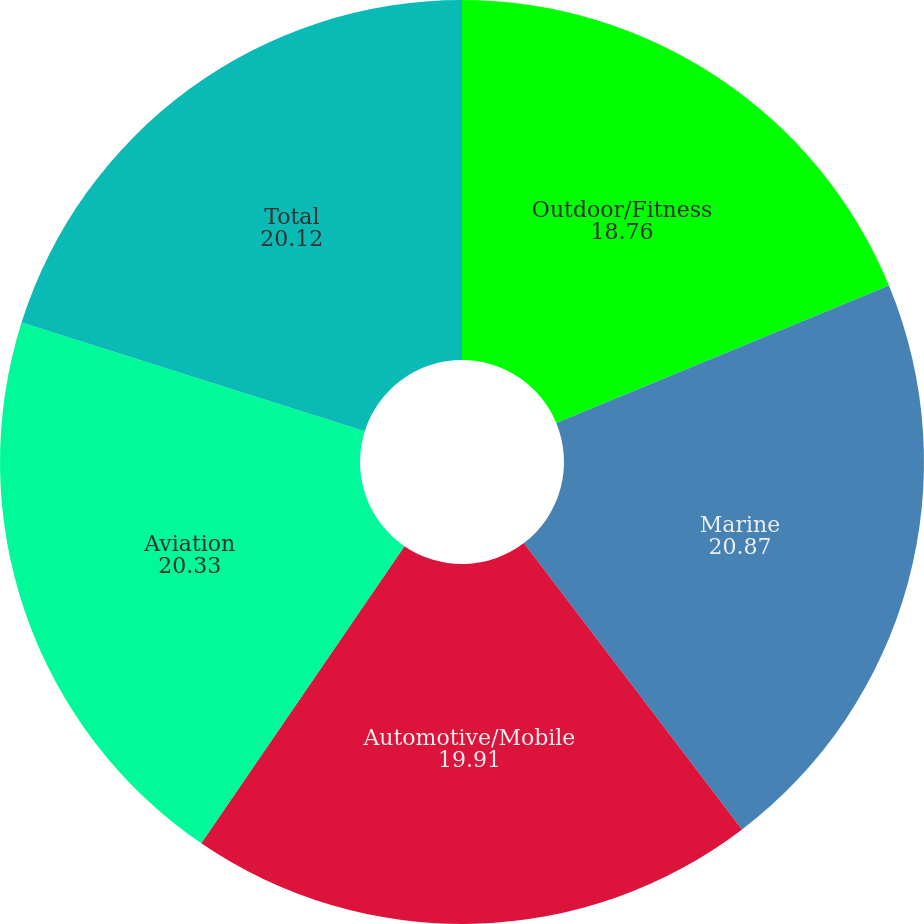Convert chart to OTSL. <chart><loc_0><loc_0><loc_500><loc_500><pie_chart><fcel>Outdoor/Fitness<fcel>Marine<fcel>Automotive/Mobile<fcel>Aviation<fcel>Total<nl><fcel>18.76%<fcel>20.87%<fcel>19.91%<fcel>20.33%<fcel>20.12%<nl></chart> 